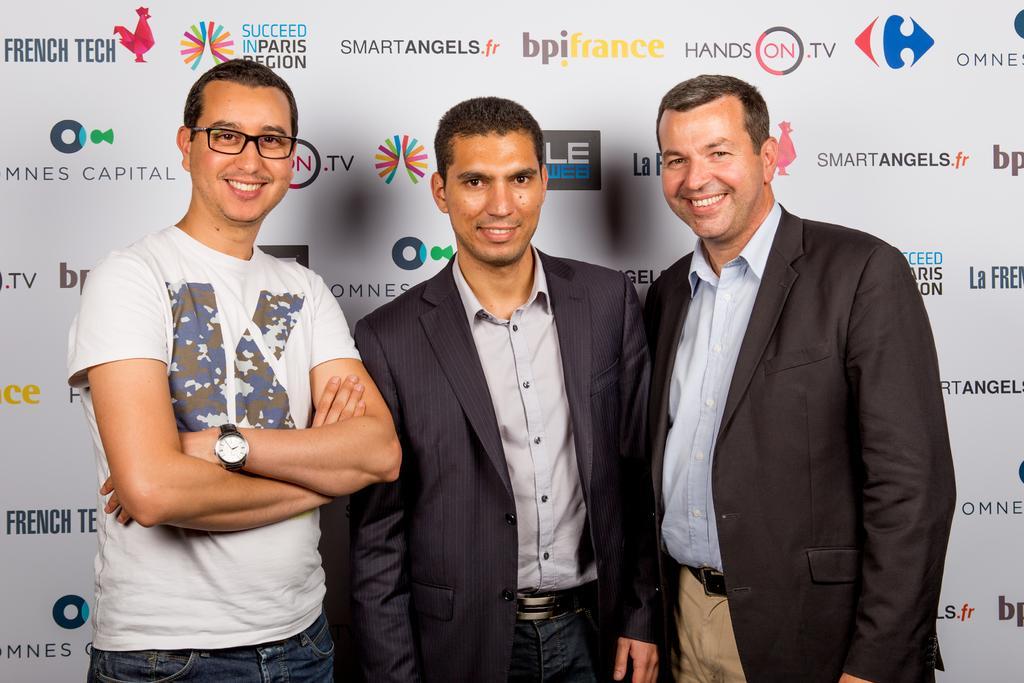How would you summarize this image in a sentence or two? In this image there are three men standing. They are smiling. Behind them there is a board. There are logos and text on the board. 